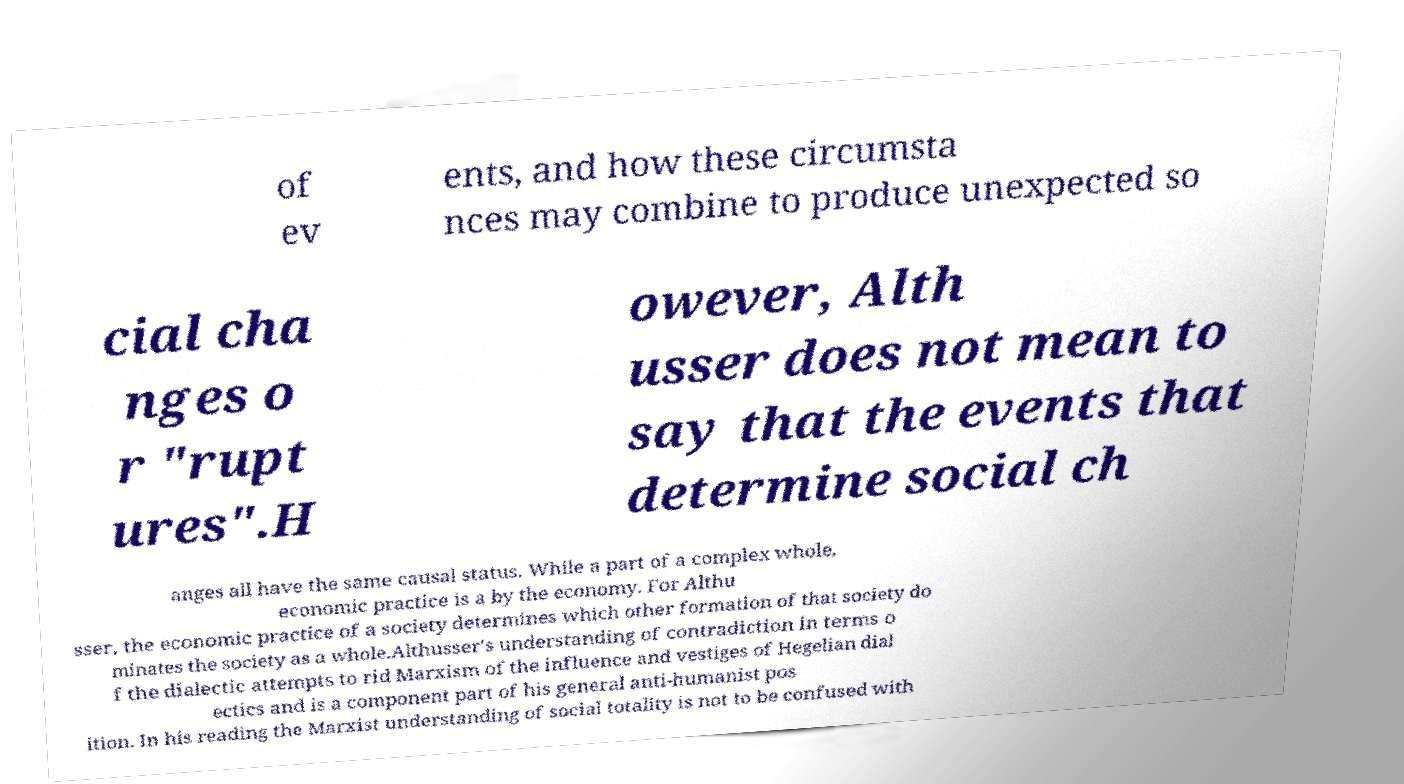There's text embedded in this image that I need extracted. Can you transcribe it verbatim? of ev ents, and how these circumsta nces may combine to produce unexpected so cial cha nges o r "rupt ures".H owever, Alth usser does not mean to say that the events that determine social ch anges all have the same causal status. While a part of a complex whole, economic practice is a by the economy. For Althu sser, the economic practice of a society determines which other formation of that society do minates the society as a whole.Althusser's understanding of contradiction in terms o f the dialectic attempts to rid Marxism of the influence and vestiges of Hegelian dial ectics and is a component part of his general anti-humanist pos ition. In his reading the Marxist understanding of social totality is not to be confused with 